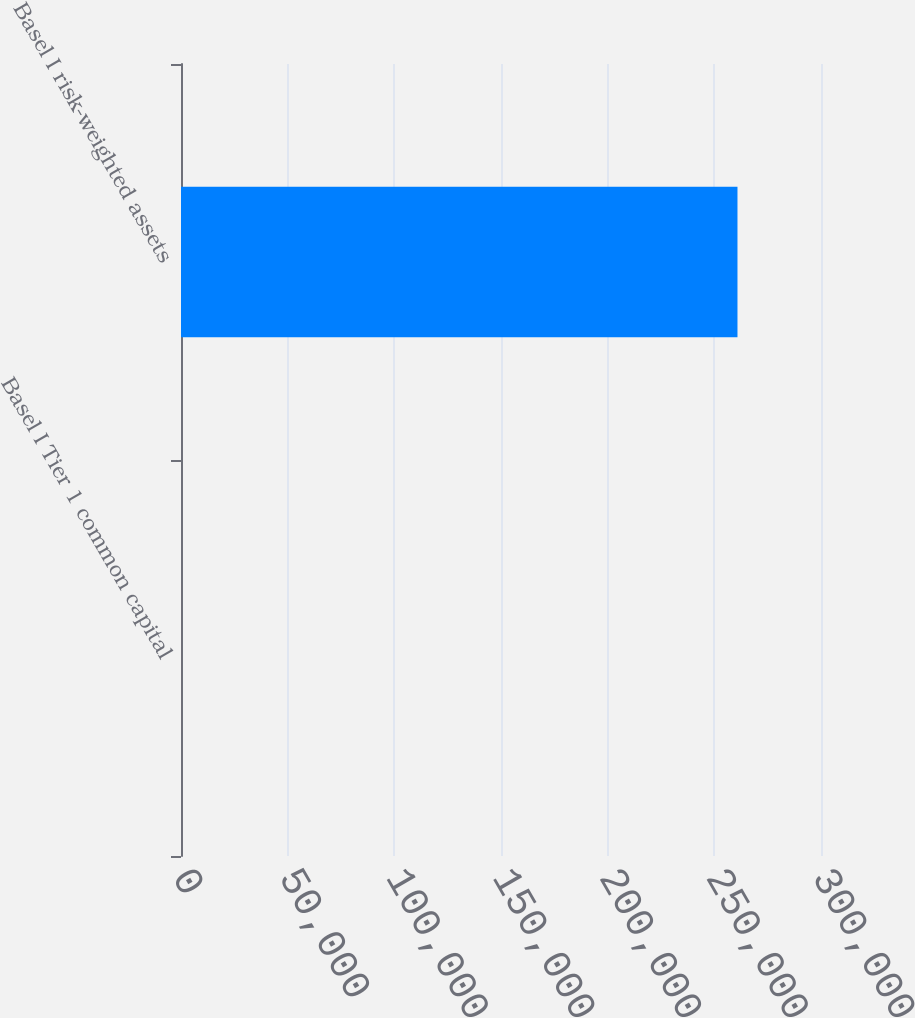Convert chart. <chart><loc_0><loc_0><loc_500><loc_500><bar_chart><fcel>Basel I Tier 1 common capital<fcel>Basel I risk-weighted assets<nl><fcel>9.6<fcel>260847<nl></chart> 